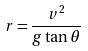Convert formula to latex. <formula><loc_0><loc_0><loc_500><loc_500>r = { \frac { v ^ { 2 } } { g \tan \theta } }</formula> 